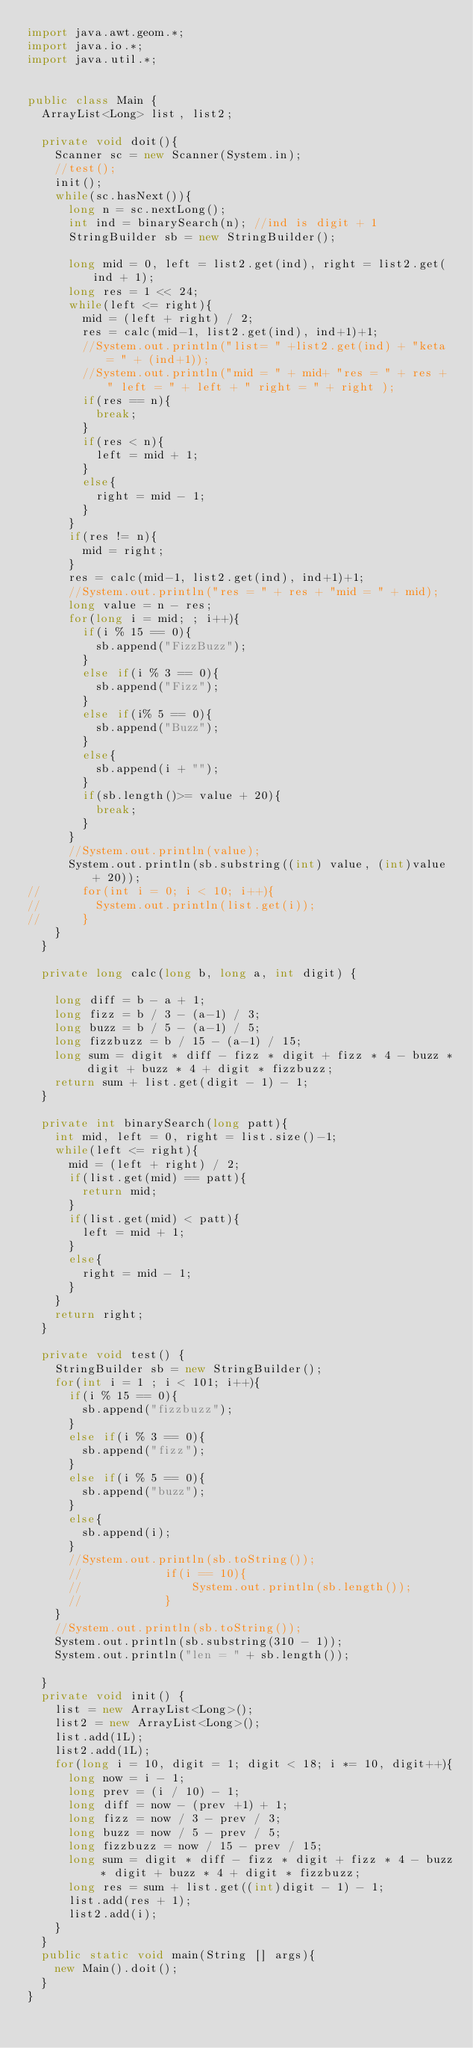Convert code to text. <code><loc_0><loc_0><loc_500><loc_500><_Java_>import java.awt.geom.*;
import java.io.*;
import java.util.*;


public class Main {
	ArrayList<Long> list, list2;

	private void doit(){
		Scanner sc = new Scanner(System.in);
		//test();
		init();
		while(sc.hasNext()){
			long n = sc.nextLong();
			int ind = binarySearch(n); //ind is digit + 1
			StringBuilder sb = new StringBuilder();
			
			long mid = 0, left = list2.get(ind), right = list2.get(ind + 1);
			long res = 1 << 24;
			while(left <= right){
				mid = (left + right) / 2;
				res = calc(mid-1, list2.get(ind), ind+1)+1;
				//System.out.println("list= " +list2.get(ind) + "keta = " + (ind+1));
				//System.out.println("mid = " + mid+ "res = " + res + " left = " + left + " right = " + right );
				if(res == n){
					break;
				}
				if(res < n){
					left = mid + 1;
				}
				else{
					right = mid - 1;
				}
			}
			if(res != n){
				mid = right;
			}
			res = calc(mid-1, list2.get(ind), ind+1)+1;
			//System.out.println("res = " + res + "mid = " + mid);
			long value = n - res;
			for(long i = mid; ; i++){
				if(i % 15 == 0){
					sb.append("FizzBuzz");
				}
				else if(i % 3 == 0){
					sb.append("Fizz");
				}
				else if(i% 5 == 0){
					sb.append("Buzz");
				}
				else{
					sb.append(i + "");
				}
				if(sb.length()>= value + 20){
					break;
				}
			}
			//System.out.println(value);
			System.out.println(sb.substring((int) value, (int)value + 20));
//			for(int i = 0; i < 10; i++){
//				System.out.println(list.get(i));
//			}
		}
	}

	private long calc(long b, long a, int digit) {
	
		long diff = b - a + 1;
		long fizz = b / 3 - (a-1) / 3;
		long buzz = b / 5 - (a-1) / 5;
		long fizzbuzz = b / 15 - (a-1) / 15;
		long sum = digit * diff - fizz * digit + fizz * 4 - buzz * digit + buzz * 4 + digit * fizzbuzz;
		return sum + list.get(digit - 1) - 1;
	}

	private int binarySearch(long patt){
		int mid, left = 0, right = list.size()-1;
		while(left <= right){
			mid = (left + right) / 2;
			if(list.get(mid) == patt){
				return mid;
			}
			if(list.get(mid) < patt){
				left = mid + 1;
			}
			else{
				right = mid - 1;
			}
		}
		return right;
	}

	private void test() {
		StringBuilder sb = new StringBuilder();
		for(int i = 1 ; i < 101; i++){
			if(i % 15 == 0){
				sb.append("fizzbuzz");
			}
			else if(i % 3 == 0){
				sb.append("fizz");
			}
			else if(i % 5 == 0){
				sb.append("buzz");
			}
			else{
				sb.append(i);
			}
			//System.out.println(sb.toString());
			//            if(i == 10){
			//                System.out.println(sb.length());
			//            }
		}
		//System.out.println(sb.toString());
		System.out.println(sb.substring(310 - 1));
		System.out.println("len = " + sb.length());

	}
	private void init() {
		list = new ArrayList<Long>();
		list2 = new ArrayList<Long>();
		list.add(1L);
		list2.add(1L);
		for(long i = 10, digit = 1; digit < 18; i *= 10, digit++){
			long now = i - 1;
			long prev = (i / 10) - 1;
			long diff = now - (prev +1) + 1;
			long fizz = now / 3 - prev / 3;
			long buzz = now / 5 - prev / 5;
			long fizzbuzz = now / 15 - prev / 15;
			long sum = digit * diff - fizz * digit + fizz * 4 - buzz * digit + buzz * 4 + digit * fizzbuzz;
			long res = sum + list.get((int)digit - 1) - 1;
			list.add(res + 1);
			list2.add(i);
		}
	}
	public static void main(String [] args){
		new Main().doit();
	}
}</code> 